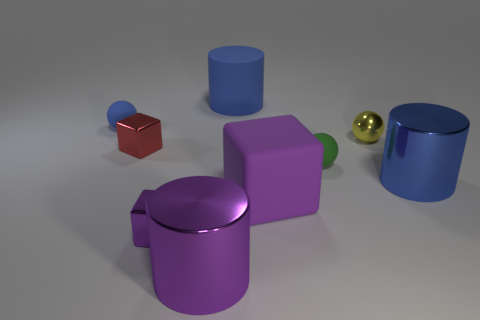What color is the big shiny cylinder that is on the left side of the tiny green rubber object?
Your response must be concise. Purple. There is a large thing that is the same color as the matte cylinder; what is its shape?
Provide a short and direct response. Cylinder. What shape is the tiny thing right of the green matte object?
Give a very brief answer. Sphere. How many gray things are either tiny blocks or shiny cylinders?
Ensure brevity in your answer.  0. Do the small green ball and the tiny yellow object have the same material?
Ensure brevity in your answer.  No. What number of tiny metal objects are in front of the yellow ball?
Keep it short and to the point. 2. What material is the object that is both on the left side of the big purple metallic cylinder and in front of the big purple rubber block?
Ensure brevity in your answer.  Metal. What number of cubes are either purple things or tiny blue rubber objects?
Offer a terse response. 2. What material is the big purple thing that is the same shape as the red metal object?
Offer a very short reply. Rubber. The blue thing that is made of the same material as the tiny purple thing is what size?
Provide a succinct answer. Large. 